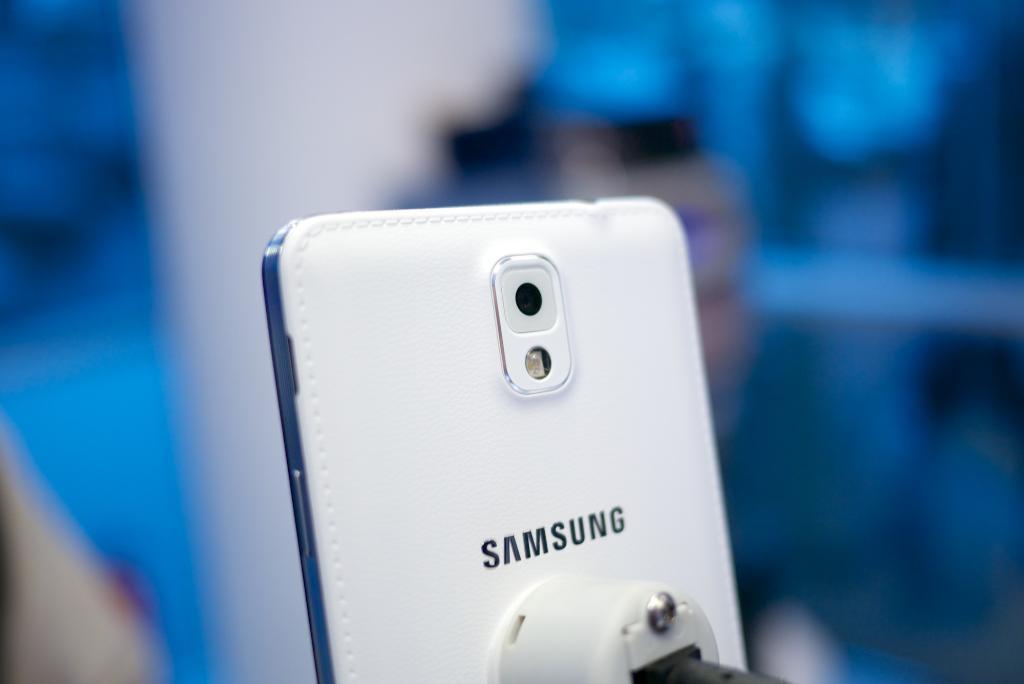In one or two sentences, can you explain what this image depicts? In this picture we can see a mobile and in the background we can see some objects and it is blurry. 